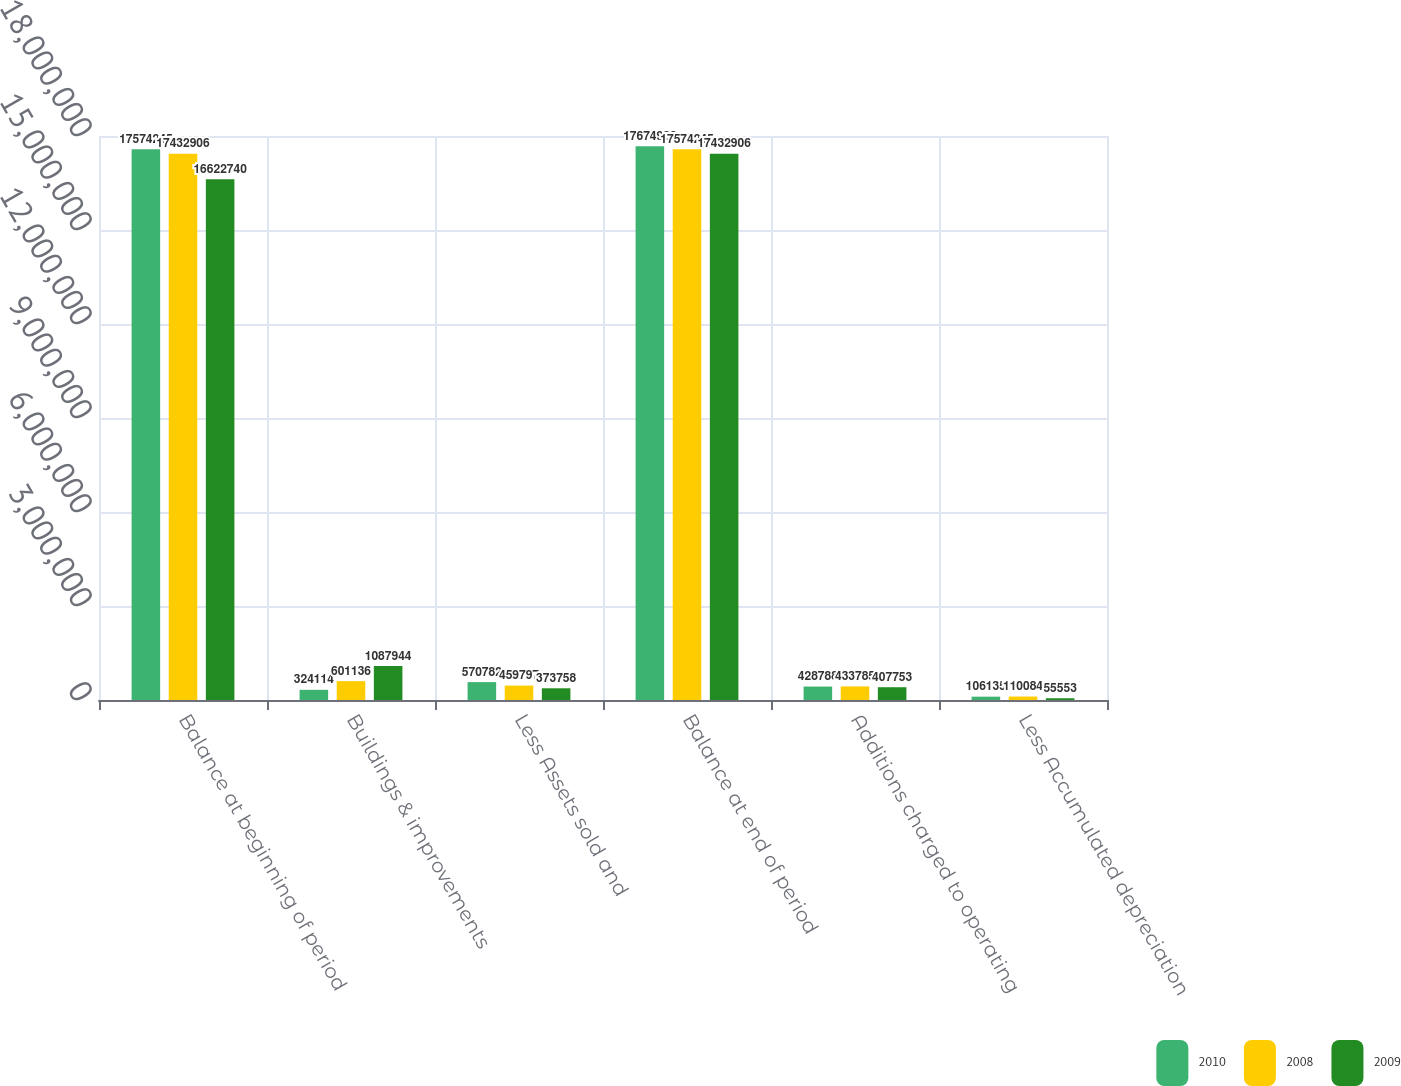Convert chart to OTSL. <chart><loc_0><loc_0><loc_500><loc_500><stacked_bar_chart><ecel><fcel>Balance at beginning of period<fcel>Buildings & improvements<fcel>Less Assets sold and<fcel>Balance at end of period<fcel>Additions charged to operating<fcel>Less Accumulated depreciation<nl><fcel>2010<fcel>1.75742e+07<fcel>324114<fcel>570782<fcel>1.76749e+07<fcel>428788<fcel>106135<nl><fcel>2008<fcel>1.74329e+07<fcel>601136<fcel>459797<fcel>1.75742e+07<fcel>433785<fcel>110084<nl><fcel>2009<fcel>1.66227e+07<fcel>1.08794e+06<fcel>373758<fcel>1.74329e+07<fcel>407753<fcel>55553<nl></chart> 